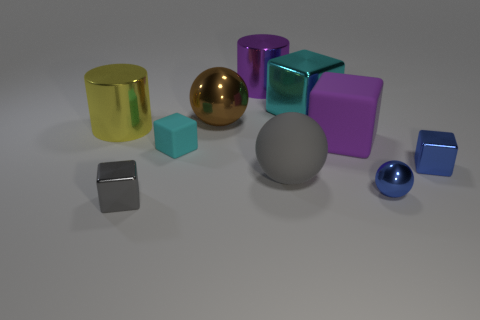There is a gray thing that is the same size as the purple matte object; what is it made of?
Your answer should be compact. Rubber. Does the matte block to the left of the cyan metallic cube have the same size as the gray block?
Your answer should be compact. Yes. There is a large matte object that is in front of the purple matte block; is its shape the same as the big brown metallic thing?
Your answer should be compact. Yes. What number of things are tiny gray rubber spheres or rubber objects left of the purple cylinder?
Offer a very short reply. 1. Are there fewer brown spheres than yellow spheres?
Ensure brevity in your answer.  No. Is the number of large brown spheres greater than the number of small purple balls?
Provide a short and direct response. Yes. What number of other objects are there of the same material as the blue sphere?
Your response must be concise. 6. There is a metal cube in front of the small metallic block that is right of the big cyan cube; what number of small cyan things are to the left of it?
Ensure brevity in your answer.  0. What number of shiny things are blue things or cylinders?
Keep it short and to the point. 4. There is a cyan cube that is on the left side of the cylinder right of the brown shiny sphere; how big is it?
Offer a terse response. Small. 